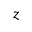Convert formula to latex. <formula><loc_0><loc_0><loc_500><loc_500>z</formula> 